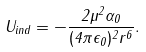<formula> <loc_0><loc_0><loc_500><loc_500>U _ { i n d } = - \frac { 2 \mu ^ { 2 } \alpha _ { 0 } } { ( 4 \pi \epsilon _ { 0 } ) ^ { 2 } r ^ { 6 } } .</formula> 